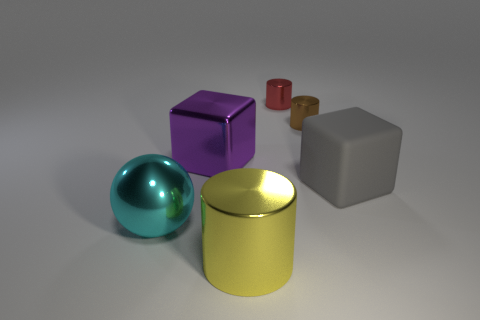Add 2 small brown cylinders. How many objects exist? 8 Add 1 red metal things. How many red metal things exist? 2 Subtract 0 cyan cylinders. How many objects are left? 6 Subtract all blocks. How many objects are left? 4 Subtract all small red spheres. Subtract all blocks. How many objects are left? 4 Add 6 tiny red metallic cylinders. How many tiny red metallic cylinders are left? 7 